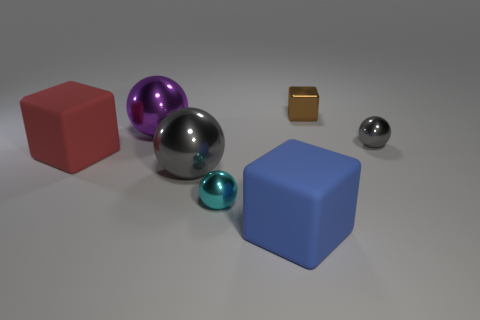Are there any small metal blocks that are on the right side of the gray metallic object that is on the right side of the small cyan thing?
Provide a succinct answer. No. What number of cylinders are either gray things or tiny objects?
Ensure brevity in your answer.  0. Are there any small cyan objects that have the same shape as the blue thing?
Make the answer very short. No. What is the shape of the tiny gray object?
Ensure brevity in your answer.  Sphere. How many things are small brown cubes or big red matte objects?
Give a very brief answer. 2. Does the gray thing that is on the right side of the blue cube have the same size as the thing that is left of the big purple sphere?
Your response must be concise. No. How many other things are made of the same material as the small block?
Provide a succinct answer. 4. Is the number of cyan things that are behind the small cyan sphere greater than the number of big red matte objects in front of the big gray thing?
Provide a succinct answer. No. There is a small sphere to the right of the tiny shiny cube; what is its material?
Provide a succinct answer. Metal. Is the shape of the large gray object the same as the big blue matte object?
Provide a short and direct response. No. 